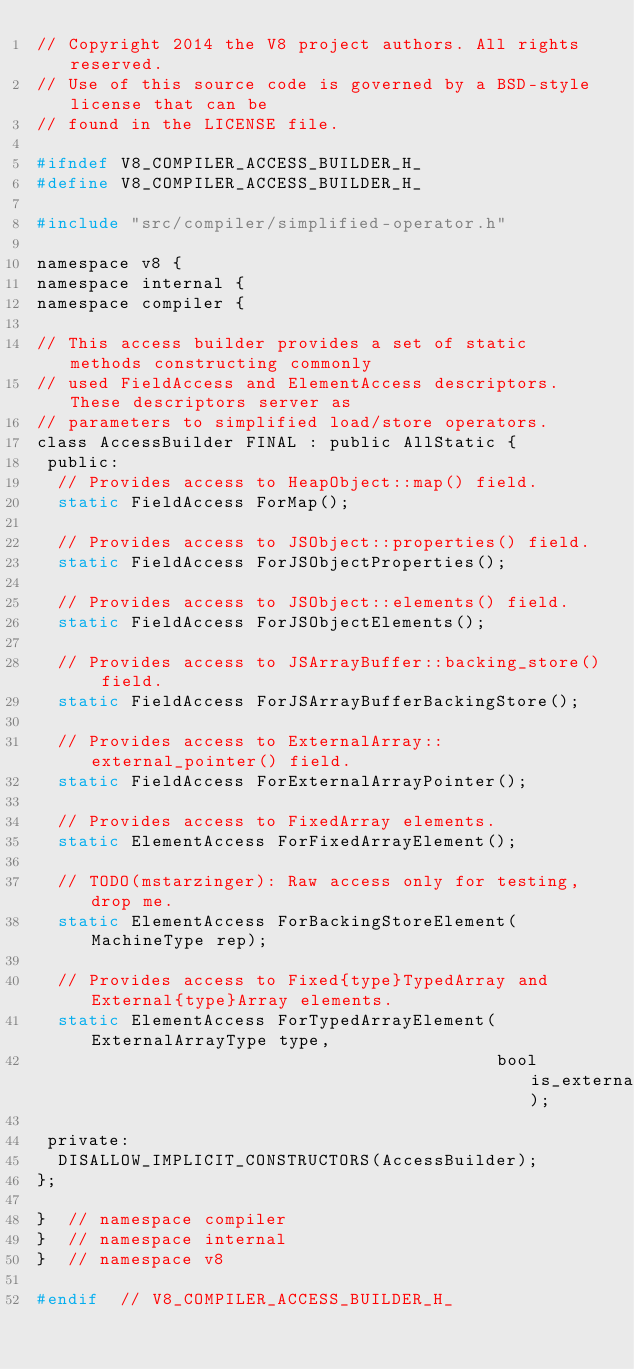<code> <loc_0><loc_0><loc_500><loc_500><_C_>// Copyright 2014 the V8 project authors. All rights reserved.
// Use of this source code is governed by a BSD-style license that can be
// found in the LICENSE file.

#ifndef V8_COMPILER_ACCESS_BUILDER_H_
#define V8_COMPILER_ACCESS_BUILDER_H_

#include "src/compiler/simplified-operator.h"

namespace v8 {
namespace internal {
namespace compiler {

// This access builder provides a set of static methods constructing commonly
// used FieldAccess and ElementAccess descriptors. These descriptors server as
// parameters to simplified load/store operators.
class AccessBuilder FINAL : public AllStatic {
 public:
  // Provides access to HeapObject::map() field.
  static FieldAccess ForMap();

  // Provides access to JSObject::properties() field.
  static FieldAccess ForJSObjectProperties();

  // Provides access to JSObject::elements() field.
  static FieldAccess ForJSObjectElements();

  // Provides access to JSArrayBuffer::backing_store() field.
  static FieldAccess ForJSArrayBufferBackingStore();

  // Provides access to ExternalArray::external_pointer() field.
  static FieldAccess ForExternalArrayPointer();

  // Provides access to FixedArray elements.
  static ElementAccess ForFixedArrayElement();

  // TODO(mstarzinger): Raw access only for testing, drop me.
  static ElementAccess ForBackingStoreElement(MachineType rep);

  // Provides access to Fixed{type}TypedArray and External{type}Array elements.
  static ElementAccess ForTypedArrayElement(ExternalArrayType type,
                                            bool is_external);

 private:
  DISALLOW_IMPLICIT_CONSTRUCTORS(AccessBuilder);
};

}  // namespace compiler
}  // namespace internal
}  // namespace v8

#endif  // V8_COMPILER_ACCESS_BUILDER_H_
</code> 